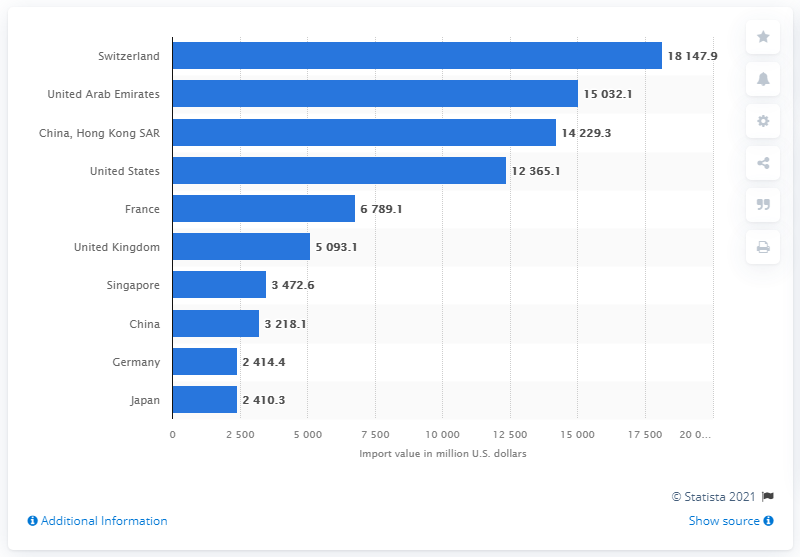Identify some key points in this picture. In 2019, the import value of Switzerland in the United States was 18,147.9 million U.S. dollars. In 2019, China imported a total of 14,229.3 million dollars' worth of goods. According to the data from 2019, Switzerland was the leading importer of gold, silverware, and jewelry. 